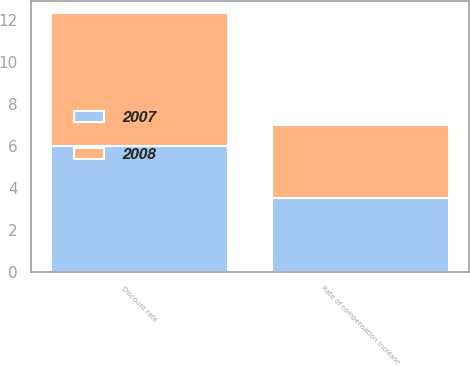Convert chart to OTSL. <chart><loc_0><loc_0><loc_500><loc_500><stacked_bar_chart><ecel><fcel>Discount rate<fcel>Rate of compensation increase<nl><fcel>2007<fcel>6<fcel>3.5<nl><fcel>2008<fcel>6.3<fcel>3.5<nl></chart> 